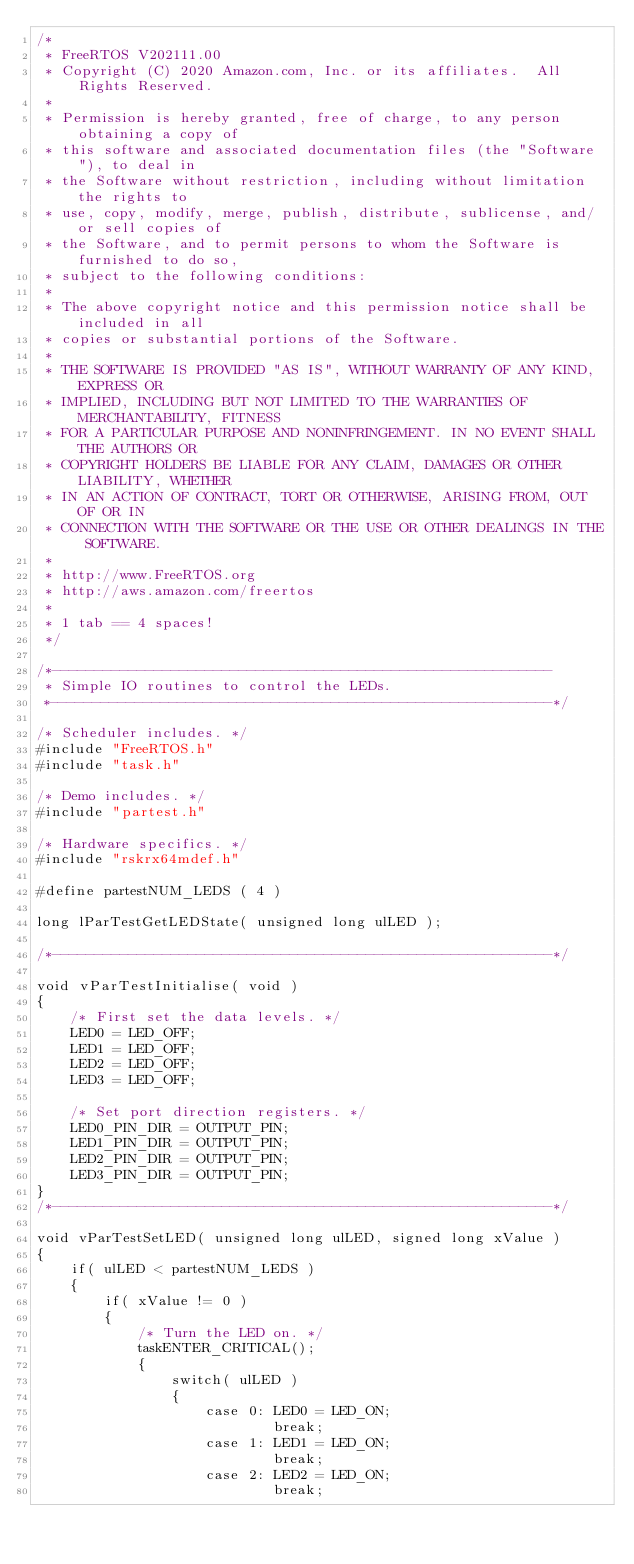Convert code to text. <code><loc_0><loc_0><loc_500><loc_500><_C_>/*
 * FreeRTOS V202111.00
 * Copyright (C) 2020 Amazon.com, Inc. or its affiliates.  All Rights Reserved.
 *
 * Permission is hereby granted, free of charge, to any person obtaining a copy of
 * this software and associated documentation files (the "Software"), to deal in
 * the Software without restriction, including without limitation the rights to
 * use, copy, modify, merge, publish, distribute, sublicense, and/or sell copies of
 * the Software, and to permit persons to whom the Software is furnished to do so,
 * subject to the following conditions:
 *
 * The above copyright notice and this permission notice shall be included in all
 * copies or substantial portions of the Software.
 *
 * THE SOFTWARE IS PROVIDED "AS IS", WITHOUT WARRANTY OF ANY KIND, EXPRESS OR
 * IMPLIED, INCLUDING BUT NOT LIMITED TO THE WARRANTIES OF MERCHANTABILITY, FITNESS
 * FOR A PARTICULAR PURPOSE AND NONINFRINGEMENT. IN NO EVENT SHALL THE AUTHORS OR
 * COPYRIGHT HOLDERS BE LIABLE FOR ANY CLAIM, DAMAGES OR OTHER LIABILITY, WHETHER
 * IN AN ACTION OF CONTRACT, TORT OR OTHERWISE, ARISING FROM, OUT OF OR IN
 * CONNECTION WITH THE SOFTWARE OR THE USE OR OTHER DEALINGS IN THE SOFTWARE.
 *
 * http://www.FreeRTOS.org
 * http://aws.amazon.com/freertos
 *
 * 1 tab == 4 spaces!
 */

/*-----------------------------------------------------------
 * Simple IO routines to control the LEDs.
 *-----------------------------------------------------------*/

/* Scheduler includes. */
#include "FreeRTOS.h"
#include "task.h"

/* Demo includes. */
#include "partest.h"

/* Hardware specifics. */
#include "rskrx64mdef.h"

#define partestNUM_LEDS ( 4 )

long lParTestGetLEDState( unsigned long ulLED );

/*-----------------------------------------------------------*/

void vParTestInitialise( void )
{
	/* First set the data levels. */
	LED0 = LED_OFF;
	LED1 = LED_OFF;
	LED2 = LED_OFF;
	LED3 = LED_OFF;

	/* Set port direction registers. */
	LED0_PIN_DIR = OUTPUT_PIN;
	LED1_PIN_DIR = OUTPUT_PIN;
	LED2_PIN_DIR = OUTPUT_PIN;
	LED3_PIN_DIR = OUTPUT_PIN;
}
/*-----------------------------------------------------------*/

void vParTestSetLED( unsigned long ulLED, signed long xValue )
{
	if( ulLED < partestNUM_LEDS )
	{
		if( xValue != 0 )
		{
			/* Turn the LED on. */
			taskENTER_CRITICAL();
			{
				switch( ulLED )
				{
					case 0:	LED0 = LED_ON;
							break;
					case 1:	LED1 = LED_ON;
							break;
					case 2:	LED2 = LED_ON;
							break;</code> 